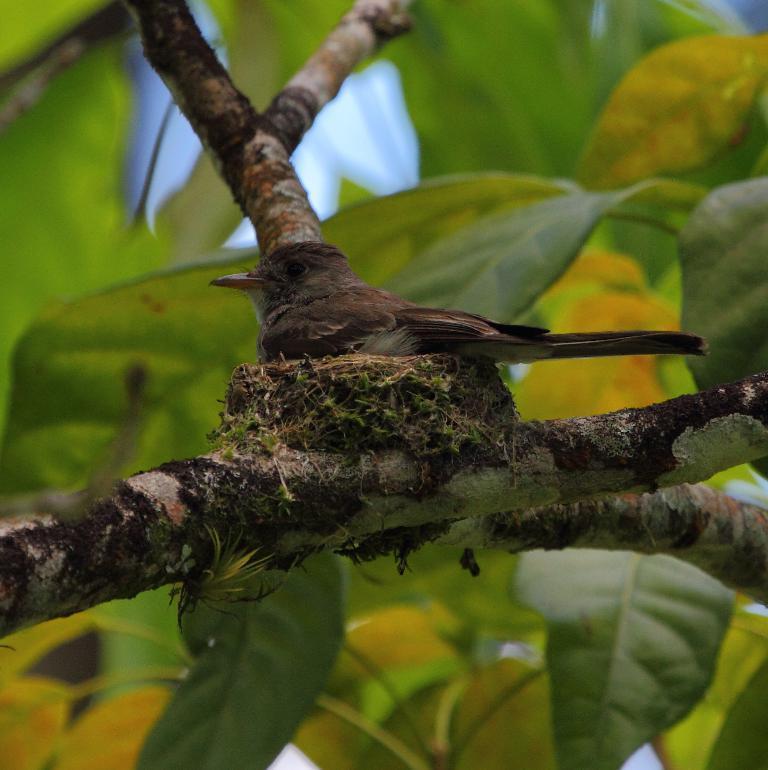Describe this image in one or two sentences. There is a bird sitting on a nest. And the nest is on a branch of a tree. In the background there are leaves. 